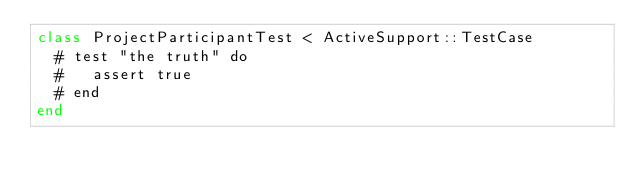Convert code to text. <code><loc_0><loc_0><loc_500><loc_500><_Ruby_>class ProjectParticipantTest < ActiveSupport::TestCase
  # test "the truth" do
  #   assert true
  # end
end
</code> 